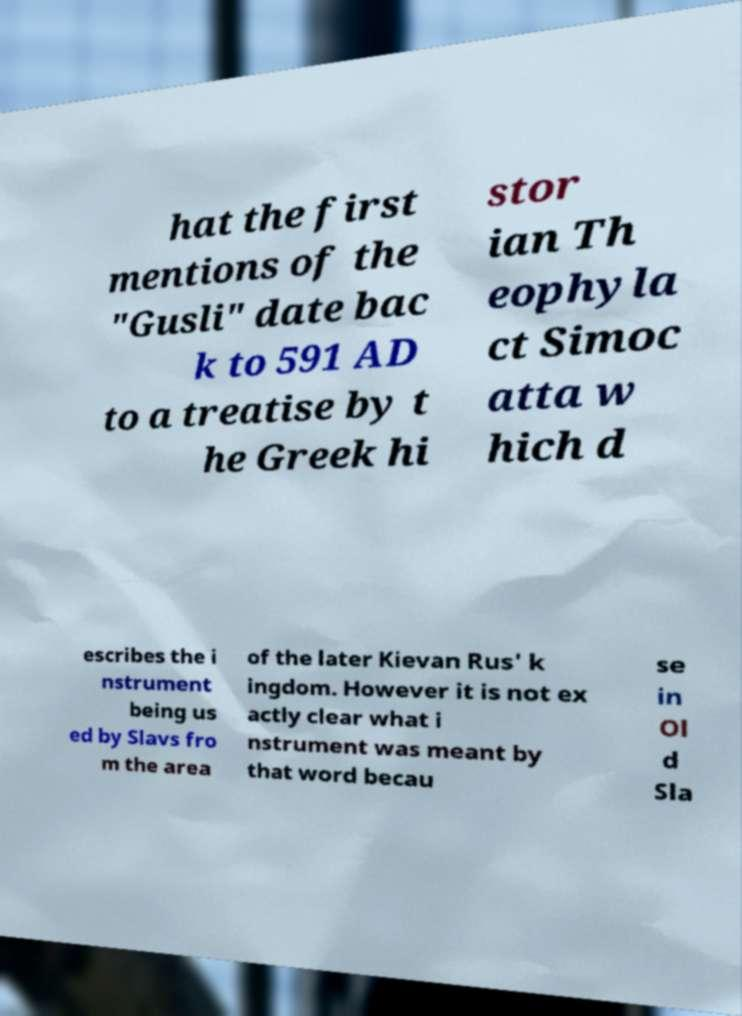Could you extract and type out the text from this image? hat the first mentions of the "Gusli" date bac k to 591 AD to a treatise by t he Greek hi stor ian Th eophyla ct Simoc atta w hich d escribes the i nstrument being us ed by Slavs fro m the area of the later Kievan Rus' k ingdom. However it is not ex actly clear what i nstrument was meant by that word becau se in Ol d Sla 